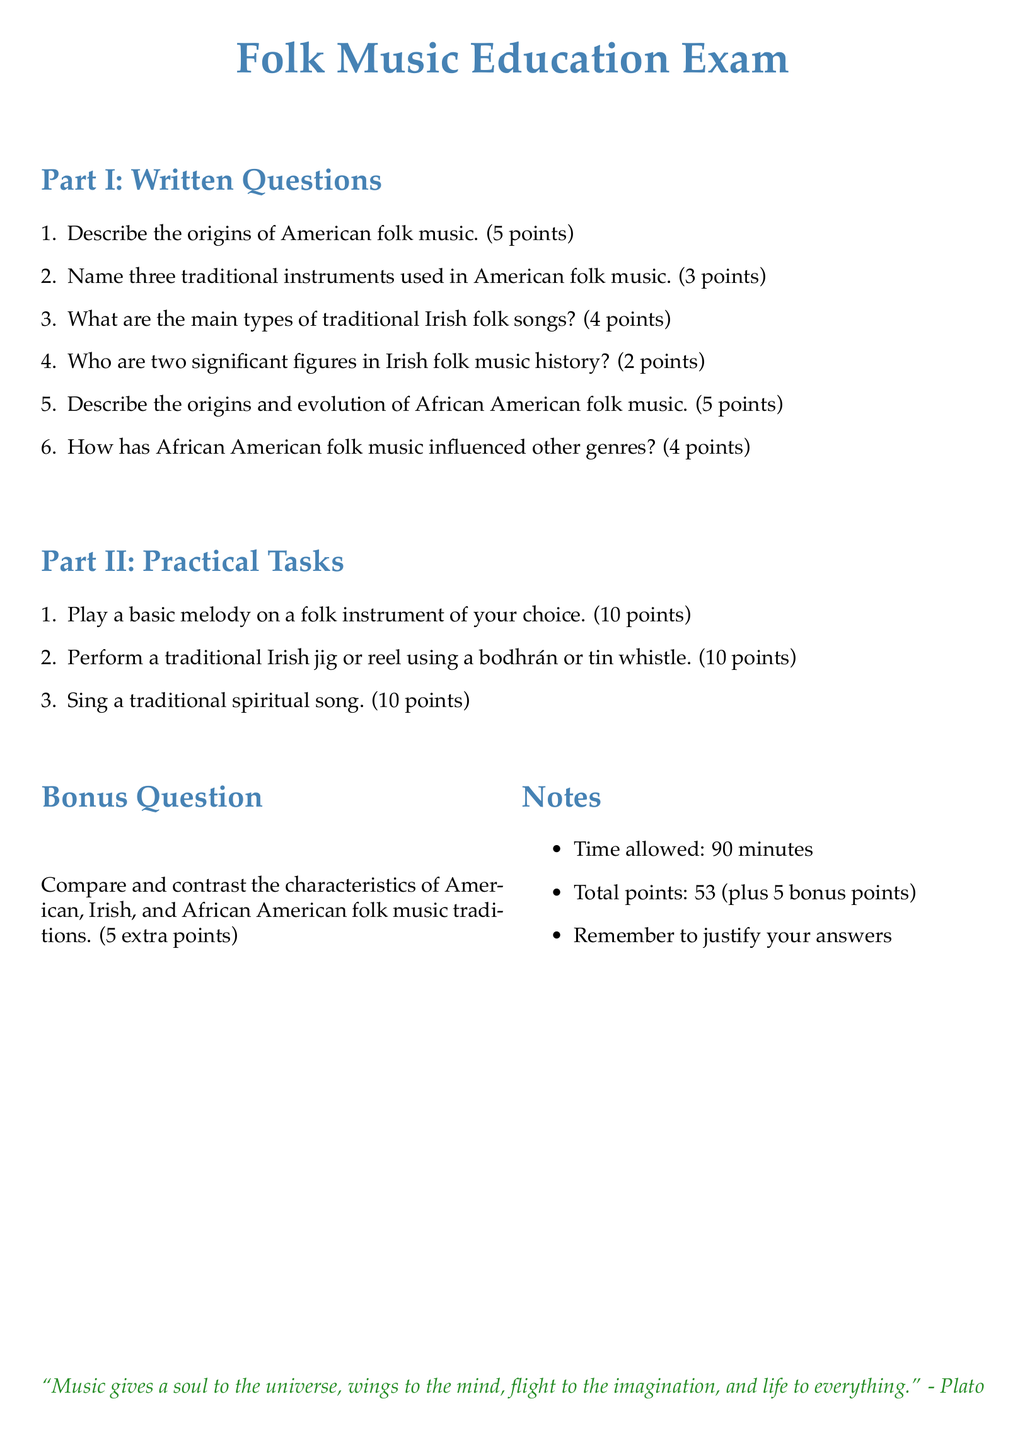what are the total points possible in the exam? The total points possible are listed in the document under the "Total points" section, which adds up to 53 plus 5 bonus points.
Answer: 53 (plus 5 bonus points) who is the quote attributed to at the bottom of the document? The quote at the bottom of the document is attributed to Plato, as indicated by the text before it.
Answer: Plato how many points can you earn for playing a melody on a folk instrument? The document specifies that playing a basic melody on a folk instrument is worth 10 points under the Practical Tasks section.
Answer: 10 points name one traditional instrument mentioned in the exam. The exam asks for three traditional instruments in American folk music, indicating that at least one example is given, as required in the Written Questions section.
Answer: (any valid example such as guitar, banjo, etc.) what is the maximum time allowed for the exam? The time allowed for completing the exam is stated in the "Notes" section of the document.
Answer: 90 minutes what is the category of the last question in the exam? The last question listed in the exam is classified as a "Bonus Question," as highlighted in the document.
Answer: Bonus Question 